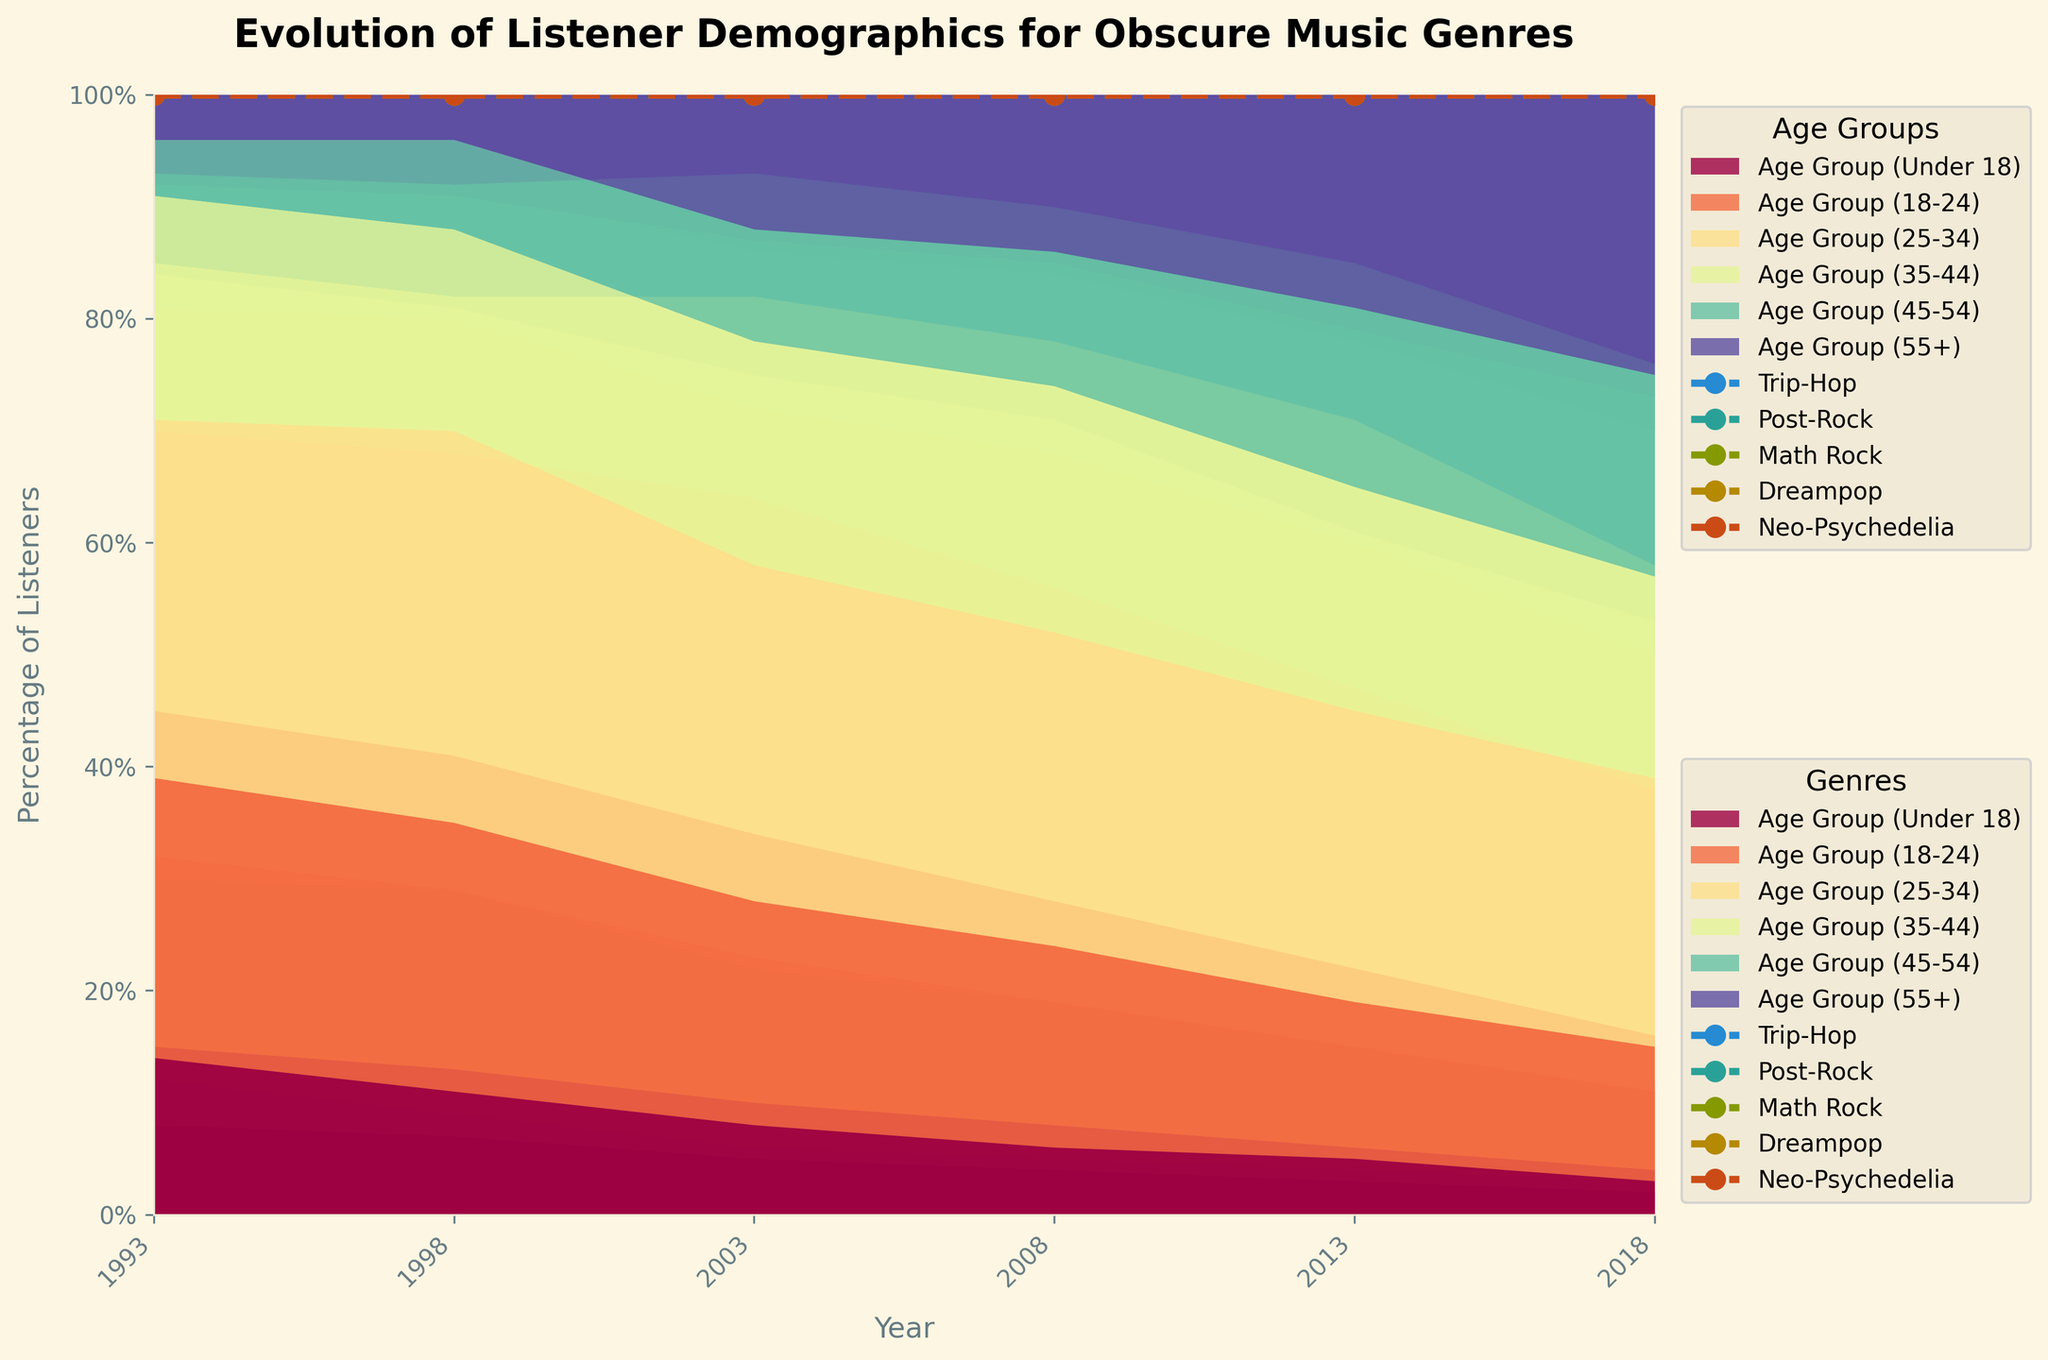What’s the title of the chart? The title can be found at the top of the figure.
Answer: Evolution of Listener Demographics for Obscure Music Genres What is the percentage range of listeners shown on the Y-axis? The Y-axis has values representing the percentage of listeners, ranging from 0% to 100%, marked in 20% increments.
Answer: 0% to 100% Which age group is marked with the darkest color? The darkest color in the plot corresponds to the last series added in the stacked area chart, representing the 55+ age group.
Answer: 55+ Which genre has the largest portion of listeners aged 18-24 in 1993? For 1993, look for the genre with the most prominent segment representing the 18-24 age group.
Answer: Dreampop Which age group has the smallest percentage change in listener demographics in the Trip-Hop genre from 1993 to 2018? To find the age group with the smallest change, compare the percentage of each age group in 1993 and 2018 for Trip-Hop.
Answer: Age Group (Under 18) How did the percentage of Post-Rock listeners aged 35-44 change from 1993 to 2018? Check the percentage values for the age group 35-44 in Post-Rock for the years 1993 and 2018 and calculate the difference (23% - 20% = 3% decrease).
Answer: Decreased by 3% Which genre shows the most significant increase in listeners aged 55+ from 1993 to 2018? Compare the difference in the percentage of listeners aged 55+ for each genre from 1993 to 2018 and identify the genre with the highest increase.
Answer: Post-Rock Between 2013 and 2018, which genre saw a decrease in the percentage of listeners aged 25-34? Check the data for each genre between 2013 and 2018 and find the genre where the percentage of listeners aged 25-34 decreased.
Answer: Math Rock, Dreampop, Neo-Psychedelia What is the trend for listeners aged 45-54 in the Neo-Psychedelia genre from 1993 to 2018? Observe the percentage values for the age group 45-54 in Neo-Psychedelia over the given years and note whether it increased, decreased, or stayed constant.
Answer: Increased Which genre had the highest percentage of under 18 listeners in 1993? Look at the first segment of the stacked area for each genre in 1993 and identify the genre with the largest size.
Answer: Dreampop 